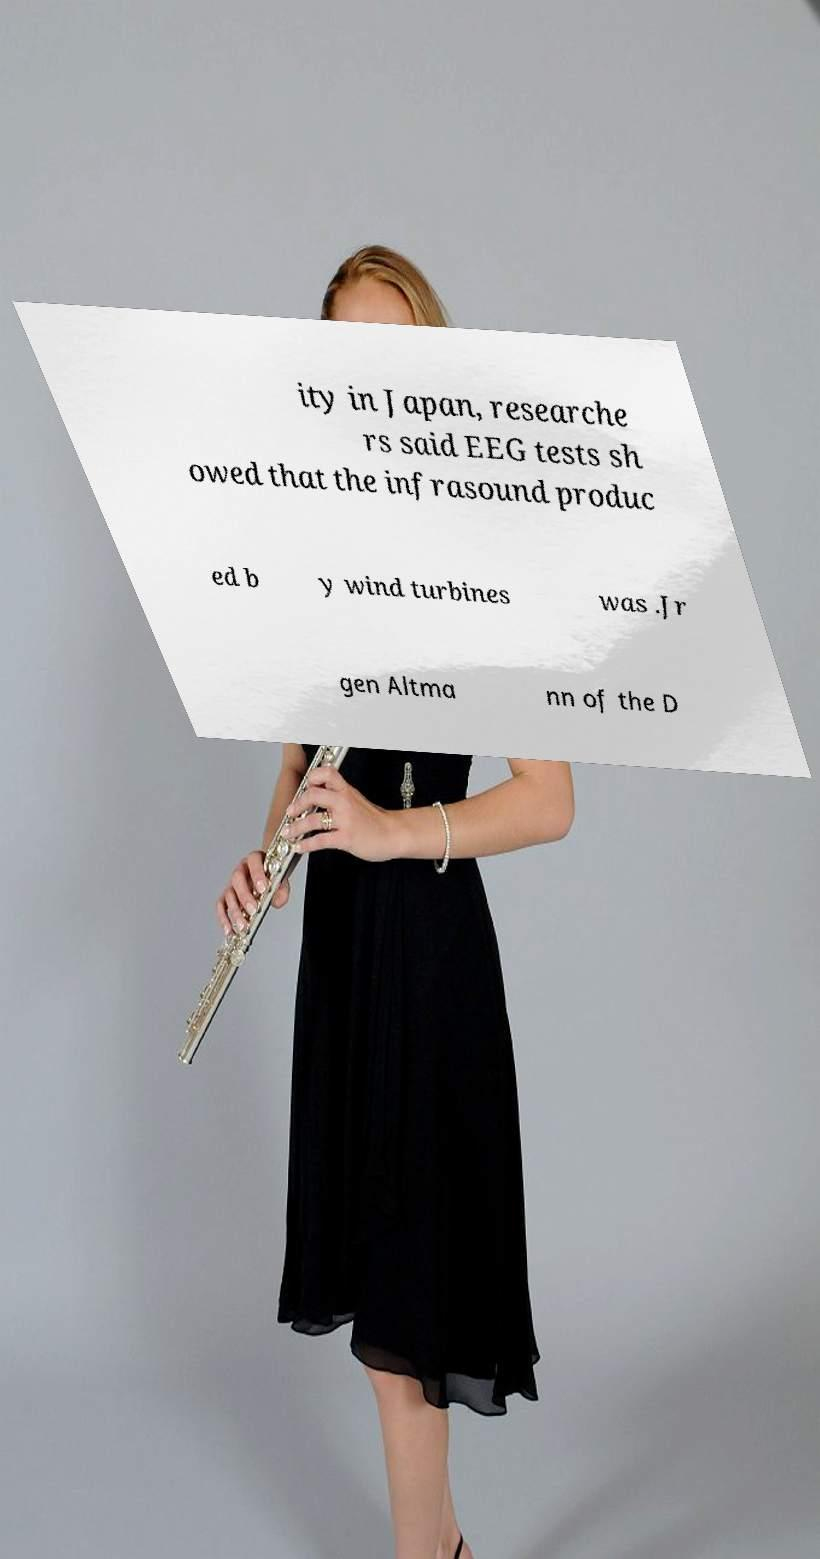Can you accurately transcribe the text from the provided image for me? ity in Japan, researche rs said EEG tests sh owed that the infrasound produc ed b y wind turbines was .Jr gen Altma nn of the D 